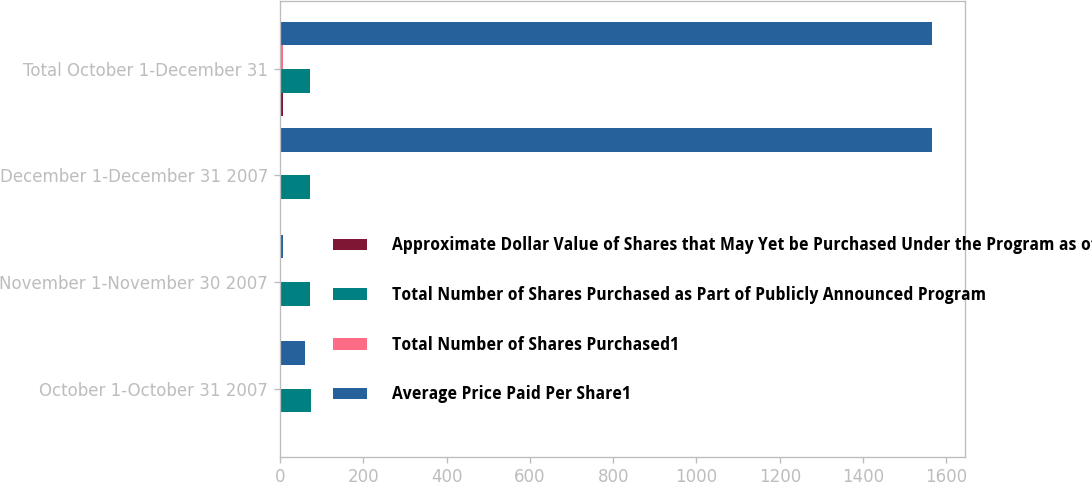Convert chart. <chart><loc_0><loc_0><loc_500><loc_500><stacked_bar_chart><ecel><fcel>October 1-October 31 2007<fcel>November 1-November 30 2007<fcel>December 1-December 31 2007<fcel>Total October 1-December 31<nl><fcel>Approximate Dollar Value of Shares that May Yet be Purchased Under the Program as of monthend<fcel>2.1<fcel>3.8<fcel>2.2<fcel>8.1<nl><fcel>Total Number of Shares Purchased as Part of Publicly Announced Program<fcel>75.58<fcel>72.19<fcel>73.04<fcel>73.31<nl><fcel>Total Number of Shares Purchased1<fcel>2.1<fcel>3.8<fcel>2.2<fcel>8.1<nl><fcel>Average Price Paid Per Share1<fcel>60<fcel>8.1<fcel>1566<fcel>1566<nl></chart> 